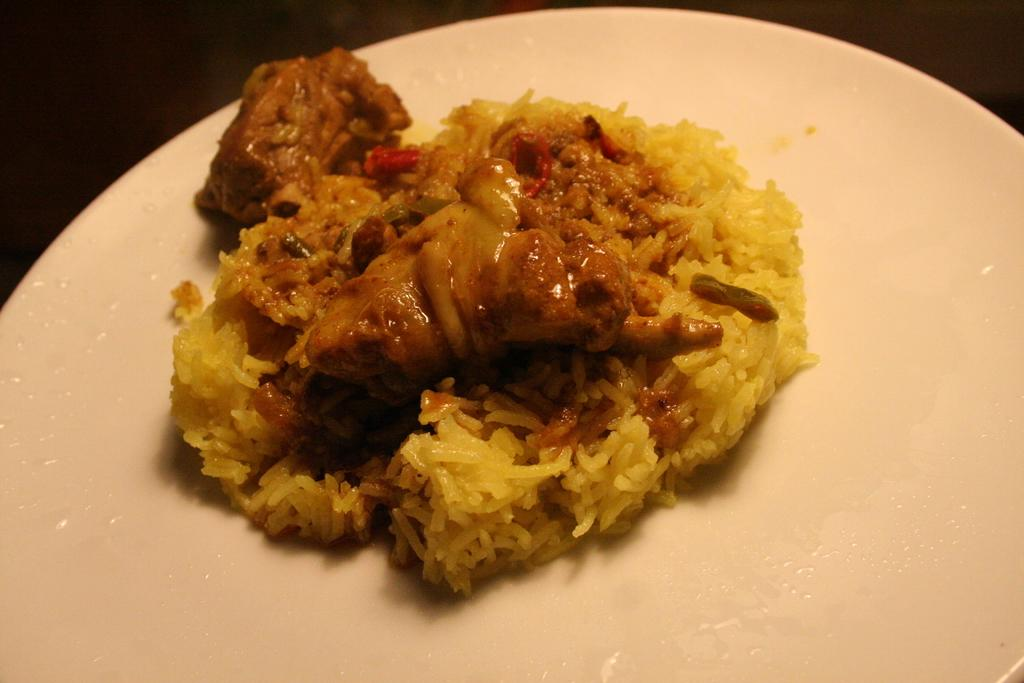What type of food is on the plate in the image? There is rice on a plate in the image. What other type of food is on a plate in the image? There is meat on a plate in the image. What type of paper is being used to cut the meat in the image? There is no paper or cutting of meat visible in the image; it only shows rice and meat on separate plates. 